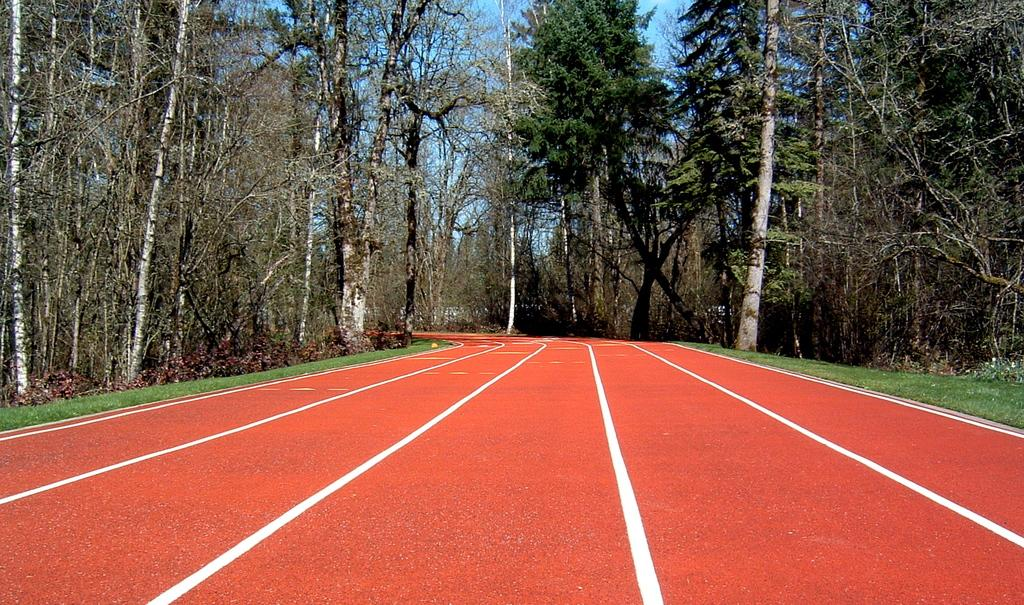What is located at the bottom of the image? There is a road and grass at the bottom of the image. What type of vegetation can be seen in the image? There are trees in the background of the image. What is visible at the top of the image? The sky is visible at the top of the image. Can you tell me how many monkeys are sitting on the road in the image? There are no monkeys present in the image; it features a road, grass, trees, and the sky. What type of home is visible in the image? There is no home visible in the image; it features a road, grass, trees, and the sky. 